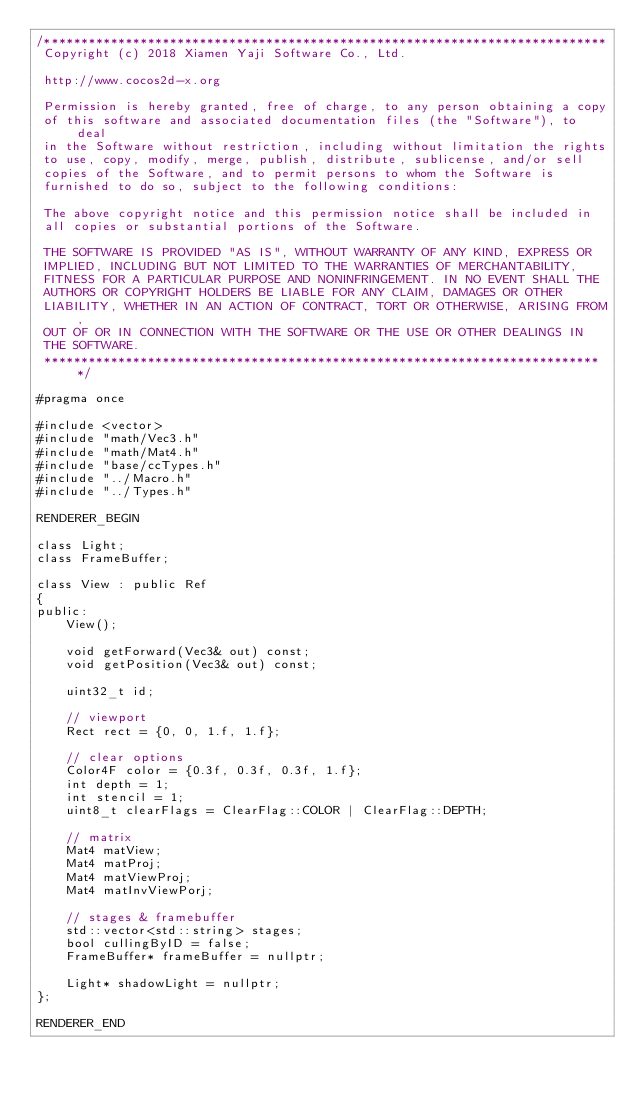Convert code to text. <code><loc_0><loc_0><loc_500><loc_500><_C_>/****************************************************************************
 Copyright (c) 2018 Xiamen Yaji Software Co., Ltd.

 http://www.cocos2d-x.org
 
 Permission is hereby granted, free of charge, to any person obtaining a copy
 of this software and associated documentation files (the "Software"), to deal
 in the Software without restriction, including without limitation the rights
 to use, copy, modify, merge, publish, distribute, sublicense, and/or sell
 copies of the Software, and to permit persons to whom the Software is
 furnished to do so, subject to the following conditions:
 
 The above copyright notice and this permission notice shall be included in
 all copies or substantial portions of the Software.
 
 THE SOFTWARE IS PROVIDED "AS IS", WITHOUT WARRANTY OF ANY KIND, EXPRESS OR
 IMPLIED, INCLUDING BUT NOT LIMITED TO THE WARRANTIES OF MERCHANTABILITY,
 FITNESS FOR A PARTICULAR PURPOSE AND NONINFRINGEMENT. IN NO EVENT SHALL THE
 AUTHORS OR COPYRIGHT HOLDERS BE LIABLE FOR ANY CLAIM, DAMAGES OR OTHER
 LIABILITY, WHETHER IN AN ACTION OF CONTRACT, TORT OR OTHERWISE, ARISING FROM,
 OUT OF OR IN CONNECTION WITH THE SOFTWARE OR THE USE OR OTHER DEALINGS IN
 THE SOFTWARE.
 ****************************************************************************/

#pragma once

#include <vector>
#include "math/Vec3.h"
#include "math/Mat4.h"
#include "base/ccTypes.h"
#include "../Macro.h"
#include "../Types.h"

RENDERER_BEGIN

class Light;
class FrameBuffer;

class View : public Ref
{
public:
    View();
    
    void getForward(Vec3& out) const;
    void getPosition(Vec3& out) const;
    
    uint32_t id;
    
    // viewport
    Rect rect = {0, 0, 1.f, 1.f};
    
    // clear options
    Color4F color = {0.3f, 0.3f, 0.3f, 1.f};
    int depth = 1;
    int stencil = 1;
    uint8_t clearFlags = ClearFlag::COLOR | ClearFlag::DEPTH;
    
    // matrix
    Mat4 matView;
    Mat4 matProj;
    Mat4 matViewProj;
    Mat4 matInvViewPorj;
    
    // stages & framebuffer
    std::vector<std::string> stages;
    bool cullingByID = false;
    FrameBuffer* frameBuffer = nullptr;
    
    Light* shadowLight = nullptr;
};

RENDERER_END
</code> 